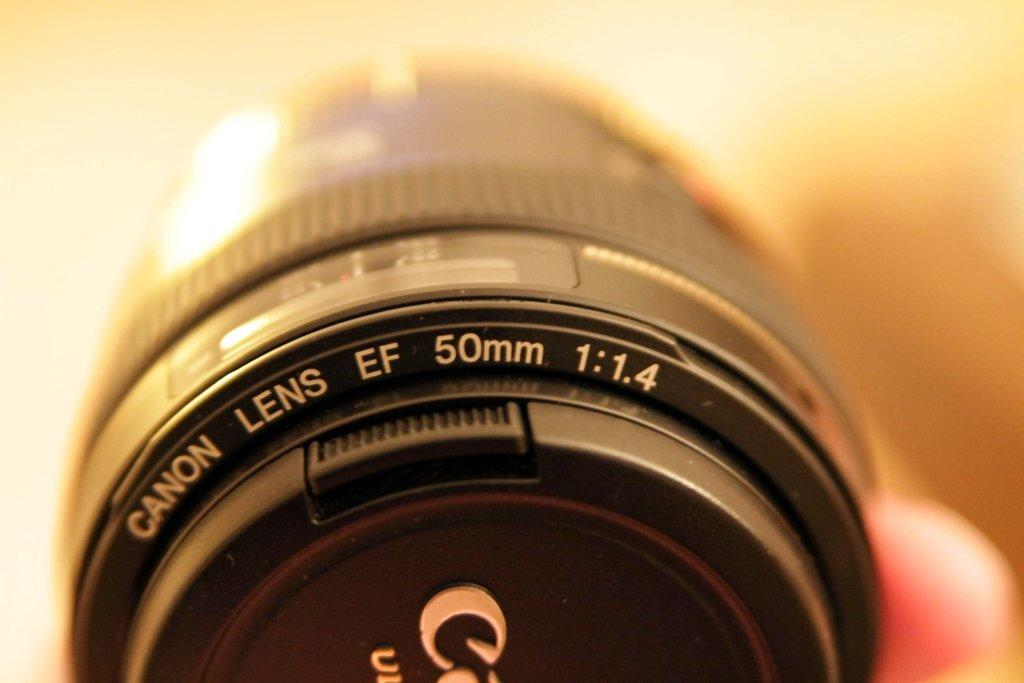What is the main subject of the picture? The main subject of the picture is a camera lens. Can you describe any specific features of the camera lens? Yes, there is text present on the camera lens. How does the pin help the camera lens take better pictures in the image? There is no pin present in the image; it only features a camera lens with text on it. 